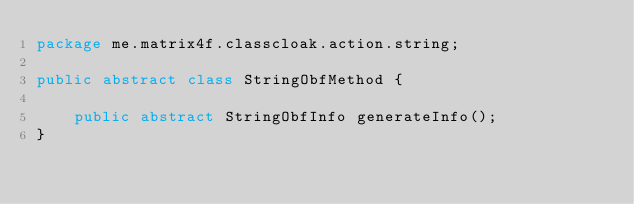Convert code to text. <code><loc_0><loc_0><loc_500><loc_500><_Java_>package me.matrix4f.classcloak.action.string;

public abstract class StringObfMethod {

    public abstract StringObfInfo generateInfo();
}
</code> 